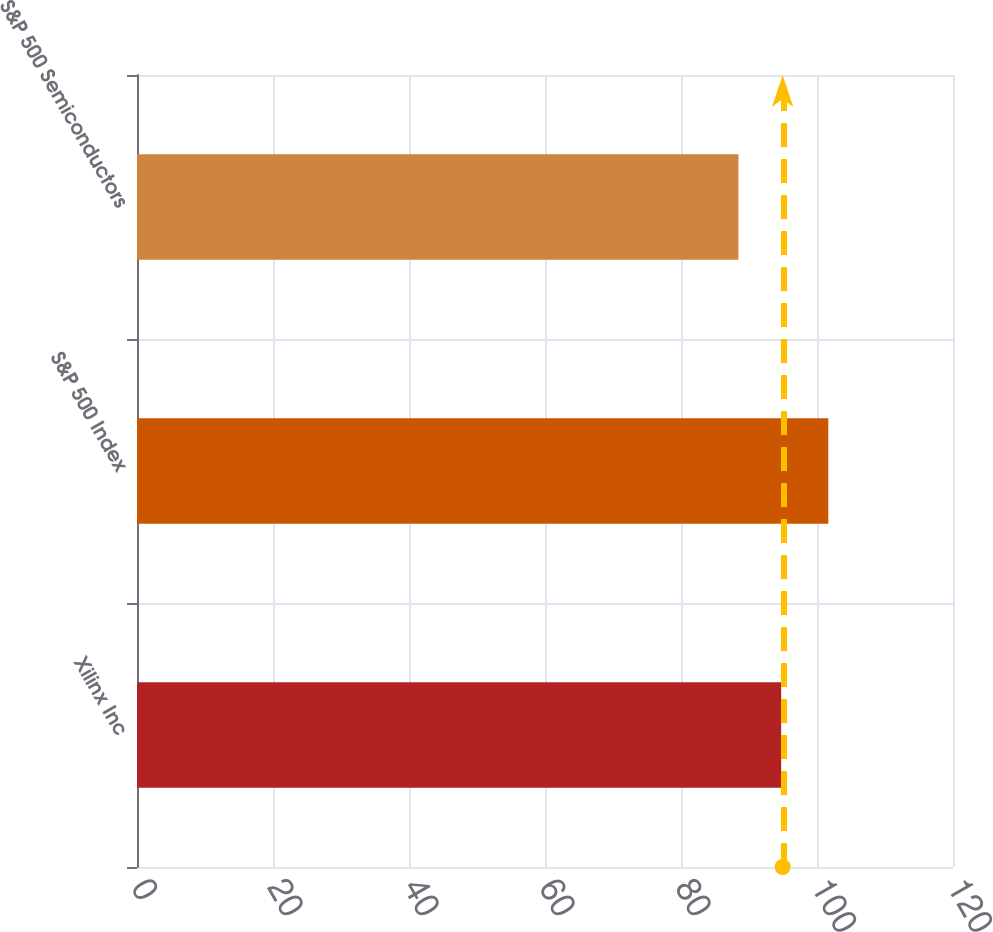Convert chart. <chart><loc_0><loc_0><loc_500><loc_500><bar_chart><fcel>Xilinx Inc<fcel>S&P 500 Index<fcel>S&P 500 Semiconductors<nl><fcel>94.73<fcel>101.66<fcel>88.45<nl></chart> 